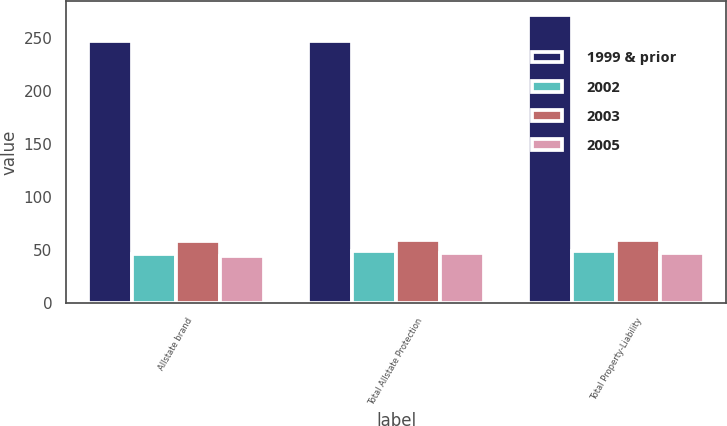Convert chart. <chart><loc_0><loc_0><loc_500><loc_500><stacked_bar_chart><ecel><fcel>Allstate brand<fcel>Total Allstate Protection<fcel>Total Property-Liability<nl><fcel>1999 & prior<fcel>247<fcel>247<fcel>271<nl><fcel>2002<fcel>46<fcel>49<fcel>49<nl><fcel>2003<fcel>58<fcel>59<fcel>59<nl><fcel>2005<fcel>44<fcel>47<fcel>47<nl></chart> 